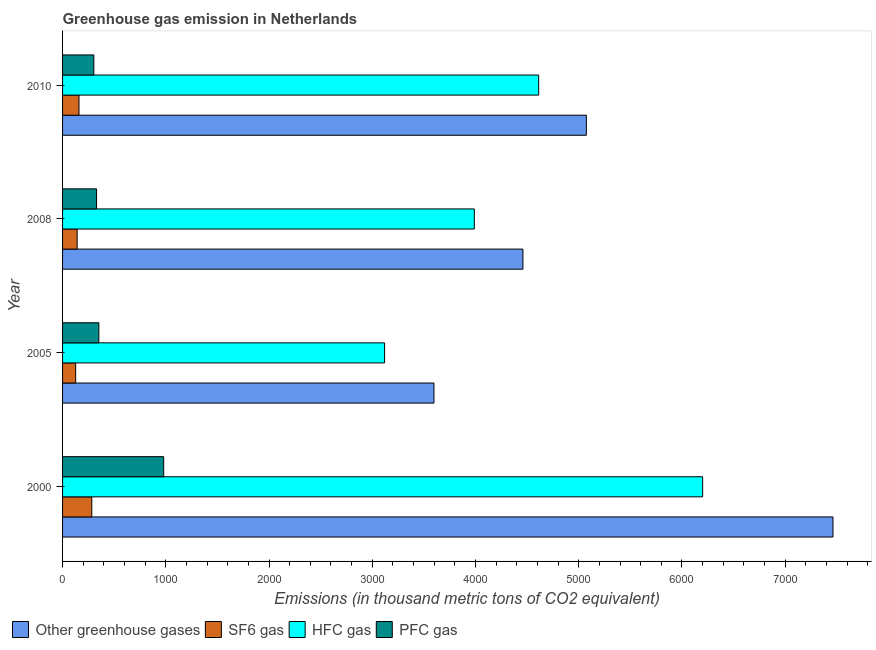How many different coloured bars are there?
Give a very brief answer. 4. Are the number of bars per tick equal to the number of legend labels?
Your answer should be very brief. Yes. How many bars are there on the 4th tick from the top?
Provide a succinct answer. 4. How many bars are there on the 3rd tick from the bottom?
Your answer should be very brief. 4. What is the label of the 1st group of bars from the top?
Give a very brief answer. 2010. What is the emission of greenhouse gases in 2008?
Keep it short and to the point. 4459.4. Across all years, what is the maximum emission of sf6 gas?
Provide a short and direct response. 283. Across all years, what is the minimum emission of pfc gas?
Ensure brevity in your answer.  303. In which year was the emission of hfc gas maximum?
Offer a very short reply. 2000. In which year was the emission of pfc gas minimum?
Keep it short and to the point. 2010. What is the total emission of hfc gas in the graph?
Provide a short and direct response. 1.79e+04. What is the difference between the emission of hfc gas in 2000 and that in 2005?
Offer a very short reply. 3080.9. What is the difference between the emission of hfc gas in 2010 and the emission of sf6 gas in 2008?
Offer a very short reply. 4470.6. What is the average emission of hfc gas per year?
Ensure brevity in your answer.  4480.18. In the year 2000, what is the difference between the emission of sf6 gas and emission of greenhouse gases?
Ensure brevity in your answer.  -7179.9. In how many years, is the emission of sf6 gas greater than 1000 thousand metric tons?
Keep it short and to the point. 0. What is the ratio of the emission of greenhouse gases in 2008 to that in 2010?
Ensure brevity in your answer.  0.88. Is the emission of pfc gas in 2005 less than that in 2008?
Ensure brevity in your answer.  No. What is the difference between the highest and the second highest emission of greenhouse gases?
Offer a very short reply. 2388.9. What is the difference between the highest and the lowest emission of sf6 gas?
Keep it short and to the point. 156.1. What does the 1st bar from the top in 2010 represents?
Offer a very short reply. PFC gas. What does the 4th bar from the bottom in 2010 represents?
Your answer should be very brief. PFC gas. Is it the case that in every year, the sum of the emission of greenhouse gases and emission of sf6 gas is greater than the emission of hfc gas?
Offer a terse response. Yes. How many bars are there?
Offer a terse response. 16. Are all the bars in the graph horizontal?
Provide a short and direct response. Yes. What is the difference between two consecutive major ticks on the X-axis?
Offer a very short reply. 1000. Are the values on the major ticks of X-axis written in scientific E-notation?
Your answer should be compact. No. Does the graph contain grids?
Offer a terse response. No. Where does the legend appear in the graph?
Give a very brief answer. Bottom left. What is the title of the graph?
Make the answer very short. Greenhouse gas emission in Netherlands. Does "Plant species" appear as one of the legend labels in the graph?
Keep it short and to the point. No. What is the label or title of the X-axis?
Offer a very short reply. Emissions (in thousand metric tons of CO2 equivalent). What is the Emissions (in thousand metric tons of CO2 equivalent) of Other greenhouse gases in 2000?
Give a very brief answer. 7462.9. What is the Emissions (in thousand metric tons of CO2 equivalent) of SF6 gas in 2000?
Provide a succinct answer. 283. What is the Emissions (in thousand metric tons of CO2 equivalent) of HFC gas in 2000?
Offer a very short reply. 6200.4. What is the Emissions (in thousand metric tons of CO2 equivalent) in PFC gas in 2000?
Offer a very short reply. 979.5. What is the Emissions (in thousand metric tons of CO2 equivalent) in Other greenhouse gases in 2005?
Keep it short and to the point. 3597.8. What is the Emissions (in thousand metric tons of CO2 equivalent) in SF6 gas in 2005?
Your response must be concise. 126.9. What is the Emissions (in thousand metric tons of CO2 equivalent) in HFC gas in 2005?
Your answer should be compact. 3119.5. What is the Emissions (in thousand metric tons of CO2 equivalent) in PFC gas in 2005?
Make the answer very short. 351.4. What is the Emissions (in thousand metric tons of CO2 equivalent) in Other greenhouse gases in 2008?
Provide a succinct answer. 4459.4. What is the Emissions (in thousand metric tons of CO2 equivalent) of SF6 gas in 2008?
Ensure brevity in your answer.  141.4. What is the Emissions (in thousand metric tons of CO2 equivalent) of HFC gas in 2008?
Offer a very short reply. 3988.8. What is the Emissions (in thousand metric tons of CO2 equivalent) in PFC gas in 2008?
Provide a short and direct response. 329.2. What is the Emissions (in thousand metric tons of CO2 equivalent) in Other greenhouse gases in 2010?
Your response must be concise. 5074. What is the Emissions (in thousand metric tons of CO2 equivalent) in SF6 gas in 2010?
Your response must be concise. 159. What is the Emissions (in thousand metric tons of CO2 equivalent) of HFC gas in 2010?
Provide a succinct answer. 4612. What is the Emissions (in thousand metric tons of CO2 equivalent) of PFC gas in 2010?
Offer a very short reply. 303. Across all years, what is the maximum Emissions (in thousand metric tons of CO2 equivalent) in Other greenhouse gases?
Provide a succinct answer. 7462.9. Across all years, what is the maximum Emissions (in thousand metric tons of CO2 equivalent) in SF6 gas?
Keep it short and to the point. 283. Across all years, what is the maximum Emissions (in thousand metric tons of CO2 equivalent) in HFC gas?
Provide a short and direct response. 6200.4. Across all years, what is the maximum Emissions (in thousand metric tons of CO2 equivalent) of PFC gas?
Provide a succinct answer. 979.5. Across all years, what is the minimum Emissions (in thousand metric tons of CO2 equivalent) of Other greenhouse gases?
Your answer should be compact. 3597.8. Across all years, what is the minimum Emissions (in thousand metric tons of CO2 equivalent) of SF6 gas?
Make the answer very short. 126.9. Across all years, what is the minimum Emissions (in thousand metric tons of CO2 equivalent) of HFC gas?
Make the answer very short. 3119.5. Across all years, what is the minimum Emissions (in thousand metric tons of CO2 equivalent) in PFC gas?
Offer a terse response. 303. What is the total Emissions (in thousand metric tons of CO2 equivalent) of Other greenhouse gases in the graph?
Make the answer very short. 2.06e+04. What is the total Emissions (in thousand metric tons of CO2 equivalent) in SF6 gas in the graph?
Make the answer very short. 710.3. What is the total Emissions (in thousand metric tons of CO2 equivalent) in HFC gas in the graph?
Give a very brief answer. 1.79e+04. What is the total Emissions (in thousand metric tons of CO2 equivalent) of PFC gas in the graph?
Provide a succinct answer. 1963.1. What is the difference between the Emissions (in thousand metric tons of CO2 equivalent) of Other greenhouse gases in 2000 and that in 2005?
Offer a terse response. 3865.1. What is the difference between the Emissions (in thousand metric tons of CO2 equivalent) of SF6 gas in 2000 and that in 2005?
Ensure brevity in your answer.  156.1. What is the difference between the Emissions (in thousand metric tons of CO2 equivalent) of HFC gas in 2000 and that in 2005?
Your answer should be very brief. 3080.9. What is the difference between the Emissions (in thousand metric tons of CO2 equivalent) of PFC gas in 2000 and that in 2005?
Your answer should be very brief. 628.1. What is the difference between the Emissions (in thousand metric tons of CO2 equivalent) in Other greenhouse gases in 2000 and that in 2008?
Provide a short and direct response. 3003.5. What is the difference between the Emissions (in thousand metric tons of CO2 equivalent) in SF6 gas in 2000 and that in 2008?
Make the answer very short. 141.6. What is the difference between the Emissions (in thousand metric tons of CO2 equivalent) of HFC gas in 2000 and that in 2008?
Keep it short and to the point. 2211.6. What is the difference between the Emissions (in thousand metric tons of CO2 equivalent) of PFC gas in 2000 and that in 2008?
Give a very brief answer. 650.3. What is the difference between the Emissions (in thousand metric tons of CO2 equivalent) in Other greenhouse gases in 2000 and that in 2010?
Make the answer very short. 2388.9. What is the difference between the Emissions (in thousand metric tons of CO2 equivalent) of SF6 gas in 2000 and that in 2010?
Provide a succinct answer. 124. What is the difference between the Emissions (in thousand metric tons of CO2 equivalent) in HFC gas in 2000 and that in 2010?
Offer a terse response. 1588.4. What is the difference between the Emissions (in thousand metric tons of CO2 equivalent) in PFC gas in 2000 and that in 2010?
Keep it short and to the point. 676.5. What is the difference between the Emissions (in thousand metric tons of CO2 equivalent) of Other greenhouse gases in 2005 and that in 2008?
Give a very brief answer. -861.6. What is the difference between the Emissions (in thousand metric tons of CO2 equivalent) of HFC gas in 2005 and that in 2008?
Ensure brevity in your answer.  -869.3. What is the difference between the Emissions (in thousand metric tons of CO2 equivalent) of Other greenhouse gases in 2005 and that in 2010?
Your answer should be very brief. -1476.2. What is the difference between the Emissions (in thousand metric tons of CO2 equivalent) of SF6 gas in 2005 and that in 2010?
Your response must be concise. -32.1. What is the difference between the Emissions (in thousand metric tons of CO2 equivalent) in HFC gas in 2005 and that in 2010?
Your answer should be compact. -1492.5. What is the difference between the Emissions (in thousand metric tons of CO2 equivalent) of PFC gas in 2005 and that in 2010?
Your answer should be compact. 48.4. What is the difference between the Emissions (in thousand metric tons of CO2 equivalent) of Other greenhouse gases in 2008 and that in 2010?
Provide a short and direct response. -614.6. What is the difference between the Emissions (in thousand metric tons of CO2 equivalent) of SF6 gas in 2008 and that in 2010?
Offer a very short reply. -17.6. What is the difference between the Emissions (in thousand metric tons of CO2 equivalent) of HFC gas in 2008 and that in 2010?
Keep it short and to the point. -623.2. What is the difference between the Emissions (in thousand metric tons of CO2 equivalent) in PFC gas in 2008 and that in 2010?
Make the answer very short. 26.2. What is the difference between the Emissions (in thousand metric tons of CO2 equivalent) in Other greenhouse gases in 2000 and the Emissions (in thousand metric tons of CO2 equivalent) in SF6 gas in 2005?
Your answer should be very brief. 7336. What is the difference between the Emissions (in thousand metric tons of CO2 equivalent) in Other greenhouse gases in 2000 and the Emissions (in thousand metric tons of CO2 equivalent) in HFC gas in 2005?
Give a very brief answer. 4343.4. What is the difference between the Emissions (in thousand metric tons of CO2 equivalent) of Other greenhouse gases in 2000 and the Emissions (in thousand metric tons of CO2 equivalent) of PFC gas in 2005?
Make the answer very short. 7111.5. What is the difference between the Emissions (in thousand metric tons of CO2 equivalent) in SF6 gas in 2000 and the Emissions (in thousand metric tons of CO2 equivalent) in HFC gas in 2005?
Provide a short and direct response. -2836.5. What is the difference between the Emissions (in thousand metric tons of CO2 equivalent) in SF6 gas in 2000 and the Emissions (in thousand metric tons of CO2 equivalent) in PFC gas in 2005?
Provide a short and direct response. -68.4. What is the difference between the Emissions (in thousand metric tons of CO2 equivalent) of HFC gas in 2000 and the Emissions (in thousand metric tons of CO2 equivalent) of PFC gas in 2005?
Your response must be concise. 5849. What is the difference between the Emissions (in thousand metric tons of CO2 equivalent) of Other greenhouse gases in 2000 and the Emissions (in thousand metric tons of CO2 equivalent) of SF6 gas in 2008?
Make the answer very short. 7321.5. What is the difference between the Emissions (in thousand metric tons of CO2 equivalent) of Other greenhouse gases in 2000 and the Emissions (in thousand metric tons of CO2 equivalent) of HFC gas in 2008?
Your answer should be compact. 3474.1. What is the difference between the Emissions (in thousand metric tons of CO2 equivalent) in Other greenhouse gases in 2000 and the Emissions (in thousand metric tons of CO2 equivalent) in PFC gas in 2008?
Provide a short and direct response. 7133.7. What is the difference between the Emissions (in thousand metric tons of CO2 equivalent) of SF6 gas in 2000 and the Emissions (in thousand metric tons of CO2 equivalent) of HFC gas in 2008?
Your answer should be very brief. -3705.8. What is the difference between the Emissions (in thousand metric tons of CO2 equivalent) of SF6 gas in 2000 and the Emissions (in thousand metric tons of CO2 equivalent) of PFC gas in 2008?
Keep it short and to the point. -46.2. What is the difference between the Emissions (in thousand metric tons of CO2 equivalent) of HFC gas in 2000 and the Emissions (in thousand metric tons of CO2 equivalent) of PFC gas in 2008?
Your response must be concise. 5871.2. What is the difference between the Emissions (in thousand metric tons of CO2 equivalent) of Other greenhouse gases in 2000 and the Emissions (in thousand metric tons of CO2 equivalent) of SF6 gas in 2010?
Provide a short and direct response. 7303.9. What is the difference between the Emissions (in thousand metric tons of CO2 equivalent) in Other greenhouse gases in 2000 and the Emissions (in thousand metric tons of CO2 equivalent) in HFC gas in 2010?
Provide a short and direct response. 2850.9. What is the difference between the Emissions (in thousand metric tons of CO2 equivalent) in Other greenhouse gases in 2000 and the Emissions (in thousand metric tons of CO2 equivalent) in PFC gas in 2010?
Provide a short and direct response. 7159.9. What is the difference between the Emissions (in thousand metric tons of CO2 equivalent) of SF6 gas in 2000 and the Emissions (in thousand metric tons of CO2 equivalent) of HFC gas in 2010?
Provide a short and direct response. -4329. What is the difference between the Emissions (in thousand metric tons of CO2 equivalent) in HFC gas in 2000 and the Emissions (in thousand metric tons of CO2 equivalent) in PFC gas in 2010?
Your response must be concise. 5897.4. What is the difference between the Emissions (in thousand metric tons of CO2 equivalent) of Other greenhouse gases in 2005 and the Emissions (in thousand metric tons of CO2 equivalent) of SF6 gas in 2008?
Offer a terse response. 3456.4. What is the difference between the Emissions (in thousand metric tons of CO2 equivalent) of Other greenhouse gases in 2005 and the Emissions (in thousand metric tons of CO2 equivalent) of HFC gas in 2008?
Offer a very short reply. -391. What is the difference between the Emissions (in thousand metric tons of CO2 equivalent) in Other greenhouse gases in 2005 and the Emissions (in thousand metric tons of CO2 equivalent) in PFC gas in 2008?
Your response must be concise. 3268.6. What is the difference between the Emissions (in thousand metric tons of CO2 equivalent) in SF6 gas in 2005 and the Emissions (in thousand metric tons of CO2 equivalent) in HFC gas in 2008?
Your answer should be compact. -3861.9. What is the difference between the Emissions (in thousand metric tons of CO2 equivalent) of SF6 gas in 2005 and the Emissions (in thousand metric tons of CO2 equivalent) of PFC gas in 2008?
Provide a short and direct response. -202.3. What is the difference between the Emissions (in thousand metric tons of CO2 equivalent) in HFC gas in 2005 and the Emissions (in thousand metric tons of CO2 equivalent) in PFC gas in 2008?
Ensure brevity in your answer.  2790.3. What is the difference between the Emissions (in thousand metric tons of CO2 equivalent) in Other greenhouse gases in 2005 and the Emissions (in thousand metric tons of CO2 equivalent) in SF6 gas in 2010?
Make the answer very short. 3438.8. What is the difference between the Emissions (in thousand metric tons of CO2 equivalent) in Other greenhouse gases in 2005 and the Emissions (in thousand metric tons of CO2 equivalent) in HFC gas in 2010?
Give a very brief answer. -1014.2. What is the difference between the Emissions (in thousand metric tons of CO2 equivalent) of Other greenhouse gases in 2005 and the Emissions (in thousand metric tons of CO2 equivalent) of PFC gas in 2010?
Provide a short and direct response. 3294.8. What is the difference between the Emissions (in thousand metric tons of CO2 equivalent) of SF6 gas in 2005 and the Emissions (in thousand metric tons of CO2 equivalent) of HFC gas in 2010?
Ensure brevity in your answer.  -4485.1. What is the difference between the Emissions (in thousand metric tons of CO2 equivalent) in SF6 gas in 2005 and the Emissions (in thousand metric tons of CO2 equivalent) in PFC gas in 2010?
Offer a very short reply. -176.1. What is the difference between the Emissions (in thousand metric tons of CO2 equivalent) in HFC gas in 2005 and the Emissions (in thousand metric tons of CO2 equivalent) in PFC gas in 2010?
Give a very brief answer. 2816.5. What is the difference between the Emissions (in thousand metric tons of CO2 equivalent) in Other greenhouse gases in 2008 and the Emissions (in thousand metric tons of CO2 equivalent) in SF6 gas in 2010?
Offer a very short reply. 4300.4. What is the difference between the Emissions (in thousand metric tons of CO2 equivalent) in Other greenhouse gases in 2008 and the Emissions (in thousand metric tons of CO2 equivalent) in HFC gas in 2010?
Keep it short and to the point. -152.6. What is the difference between the Emissions (in thousand metric tons of CO2 equivalent) in Other greenhouse gases in 2008 and the Emissions (in thousand metric tons of CO2 equivalent) in PFC gas in 2010?
Your response must be concise. 4156.4. What is the difference between the Emissions (in thousand metric tons of CO2 equivalent) in SF6 gas in 2008 and the Emissions (in thousand metric tons of CO2 equivalent) in HFC gas in 2010?
Provide a succinct answer. -4470.6. What is the difference between the Emissions (in thousand metric tons of CO2 equivalent) in SF6 gas in 2008 and the Emissions (in thousand metric tons of CO2 equivalent) in PFC gas in 2010?
Your response must be concise. -161.6. What is the difference between the Emissions (in thousand metric tons of CO2 equivalent) in HFC gas in 2008 and the Emissions (in thousand metric tons of CO2 equivalent) in PFC gas in 2010?
Make the answer very short. 3685.8. What is the average Emissions (in thousand metric tons of CO2 equivalent) of Other greenhouse gases per year?
Keep it short and to the point. 5148.52. What is the average Emissions (in thousand metric tons of CO2 equivalent) in SF6 gas per year?
Ensure brevity in your answer.  177.57. What is the average Emissions (in thousand metric tons of CO2 equivalent) in HFC gas per year?
Give a very brief answer. 4480.18. What is the average Emissions (in thousand metric tons of CO2 equivalent) of PFC gas per year?
Your response must be concise. 490.77. In the year 2000, what is the difference between the Emissions (in thousand metric tons of CO2 equivalent) in Other greenhouse gases and Emissions (in thousand metric tons of CO2 equivalent) in SF6 gas?
Provide a short and direct response. 7179.9. In the year 2000, what is the difference between the Emissions (in thousand metric tons of CO2 equivalent) in Other greenhouse gases and Emissions (in thousand metric tons of CO2 equivalent) in HFC gas?
Provide a succinct answer. 1262.5. In the year 2000, what is the difference between the Emissions (in thousand metric tons of CO2 equivalent) in Other greenhouse gases and Emissions (in thousand metric tons of CO2 equivalent) in PFC gas?
Your response must be concise. 6483.4. In the year 2000, what is the difference between the Emissions (in thousand metric tons of CO2 equivalent) of SF6 gas and Emissions (in thousand metric tons of CO2 equivalent) of HFC gas?
Keep it short and to the point. -5917.4. In the year 2000, what is the difference between the Emissions (in thousand metric tons of CO2 equivalent) of SF6 gas and Emissions (in thousand metric tons of CO2 equivalent) of PFC gas?
Give a very brief answer. -696.5. In the year 2000, what is the difference between the Emissions (in thousand metric tons of CO2 equivalent) of HFC gas and Emissions (in thousand metric tons of CO2 equivalent) of PFC gas?
Your answer should be very brief. 5220.9. In the year 2005, what is the difference between the Emissions (in thousand metric tons of CO2 equivalent) of Other greenhouse gases and Emissions (in thousand metric tons of CO2 equivalent) of SF6 gas?
Keep it short and to the point. 3470.9. In the year 2005, what is the difference between the Emissions (in thousand metric tons of CO2 equivalent) in Other greenhouse gases and Emissions (in thousand metric tons of CO2 equivalent) in HFC gas?
Keep it short and to the point. 478.3. In the year 2005, what is the difference between the Emissions (in thousand metric tons of CO2 equivalent) in Other greenhouse gases and Emissions (in thousand metric tons of CO2 equivalent) in PFC gas?
Offer a terse response. 3246.4. In the year 2005, what is the difference between the Emissions (in thousand metric tons of CO2 equivalent) of SF6 gas and Emissions (in thousand metric tons of CO2 equivalent) of HFC gas?
Your answer should be compact. -2992.6. In the year 2005, what is the difference between the Emissions (in thousand metric tons of CO2 equivalent) of SF6 gas and Emissions (in thousand metric tons of CO2 equivalent) of PFC gas?
Make the answer very short. -224.5. In the year 2005, what is the difference between the Emissions (in thousand metric tons of CO2 equivalent) in HFC gas and Emissions (in thousand metric tons of CO2 equivalent) in PFC gas?
Offer a terse response. 2768.1. In the year 2008, what is the difference between the Emissions (in thousand metric tons of CO2 equivalent) in Other greenhouse gases and Emissions (in thousand metric tons of CO2 equivalent) in SF6 gas?
Offer a terse response. 4318. In the year 2008, what is the difference between the Emissions (in thousand metric tons of CO2 equivalent) of Other greenhouse gases and Emissions (in thousand metric tons of CO2 equivalent) of HFC gas?
Ensure brevity in your answer.  470.6. In the year 2008, what is the difference between the Emissions (in thousand metric tons of CO2 equivalent) in Other greenhouse gases and Emissions (in thousand metric tons of CO2 equivalent) in PFC gas?
Your answer should be compact. 4130.2. In the year 2008, what is the difference between the Emissions (in thousand metric tons of CO2 equivalent) in SF6 gas and Emissions (in thousand metric tons of CO2 equivalent) in HFC gas?
Your answer should be compact. -3847.4. In the year 2008, what is the difference between the Emissions (in thousand metric tons of CO2 equivalent) of SF6 gas and Emissions (in thousand metric tons of CO2 equivalent) of PFC gas?
Provide a short and direct response. -187.8. In the year 2008, what is the difference between the Emissions (in thousand metric tons of CO2 equivalent) of HFC gas and Emissions (in thousand metric tons of CO2 equivalent) of PFC gas?
Keep it short and to the point. 3659.6. In the year 2010, what is the difference between the Emissions (in thousand metric tons of CO2 equivalent) in Other greenhouse gases and Emissions (in thousand metric tons of CO2 equivalent) in SF6 gas?
Provide a short and direct response. 4915. In the year 2010, what is the difference between the Emissions (in thousand metric tons of CO2 equivalent) in Other greenhouse gases and Emissions (in thousand metric tons of CO2 equivalent) in HFC gas?
Your answer should be very brief. 462. In the year 2010, what is the difference between the Emissions (in thousand metric tons of CO2 equivalent) in Other greenhouse gases and Emissions (in thousand metric tons of CO2 equivalent) in PFC gas?
Give a very brief answer. 4771. In the year 2010, what is the difference between the Emissions (in thousand metric tons of CO2 equivalent) of SF6 gas and Emissions (in thousand metric tons of CO2 equivalent) of HFC gas?
Make the answer very short. -4453. In the year 2010, what is the difference between the Emissions (in thousand metric tons of CO2 equivalent) in SF6 gas and Emissions (in thousand metric tons of CO2 equivalent) in PFC gas?
Provide a short and direct response. -144. In the year 2010, what is the difference between the Emissions (in thousand metric tons of CO2 equivalent) of HFC gas and Emissions (in thousand metric tons of CO2 equivalent) of PFC gas?
Keep it short and to the point. 4309. What is the ratio of the Emissions (in thousand metric tons of CO2 equivalent) of Other greenhouse gases in 2000 to that in 2005?
Offer a terse response. 2.07. What is the ratio of the Emissions (in thousand metric tons of CO2 equivalent) of SF6 gas in 2000 to that in 2005?
Provide a succinct answer. 2.23. What is the ratio of the Emissions (in thousand metric tons of CO2 equivalent) in HFC gas in 2000 to that in 2005?
Your response must be concise. 1.99. What is the ratio of the Emissions (in thousand metric tons of CO2 equivalent) of PFC gas in 2000 to that in 2005?
Ensure brevity in your answer.  2.79. What is the ratio of the Emissions (in thousand metric tons of CO2 equivalent) of Other greenhouse gases in 2000 to that in 2008?
Give a very brief answer. 1.67. What is the ratio of the Emissions (in thousand metric tons of CO2 equivalent) in SF6 gas in 2000 to that in 2008?
Keep it short and to the point. 2. What is the ratio of the Emissions (in thousand metric tons of CO2 equivalent) in HFC gas in 2000 to that in 2008?
Provide a short and direct response. 1.55. What is the ratio of the Emissions (in thousand metric tons of CO2 equivalent) in PFC gas in 2000 to that in 2008?
Make the answer very short. 2.98. What is the ratio of the Emissions (in thousand metric tons of CO2 equivalent) in Other greenhouse gases in 2000 to that in 2010?
Your answer should be very brief. 1.47. What is the ratio of the Emissions (in thousand metric tons of CO2 equivalent) of SF6 gas in 2000 to that in 2010?
Give a very brief answer. 1.78. What is the ratio of the Emissions (in thousand metric tons of CO2 equivalent) in HFC gas in 2000 to that in 2010?
Keep it short and to the point. 1.34. What is the ratio of the Emissions (in thousand metric tons of CO2 equivalent) of PFC gas in 2000 to that in 2010?
Your answer should be very brief. 3.23. What is the ratio of the Emissions (in thousand metric tons of CO2 equivalent) of Other greenhouse gases in 2005 to that in 2008?
Your answer should be compact. 0.81. What is the ratio of the Emissions (in thousand metric tons of CO2 equivalent) in SF6 gas in 2005 to that in 2008?
Ensure brevity in your answer.  0.9. What is the ratio of the Emissions (in thousand metric tons of CO2 equivalent) of HFC gas in 2005 to that in 2008?
Make the answer very short. 0.78. What is the ratio of the Emissions (in thousand metric tons of CO2 equivalent) in PFC gas in 2005 to that in 2008?
Ensure brevity in your answer.  1.07. What is the ratio of the Emissions (in thousand metric tons of CO2 equivalent) in Other greenhouse gases in 2005 to that in 2010?
Keep it short and to the point. 0.71. What is the ratio of the Emissions (in thousand metric tons of CO2 equivalent) of SF6 gas in 2005 to that in 2010?
Make the answer very short. 0.8. What is the ratio of the Emissions (in thousand metric tons of CO2 equivalent) in HFC gas in 2005 to that in 2010?
Provide a succinct answer. 0.68. What is the ratio of the Emissions (in thousand metric tons of CO2 equivalent) of PFC gas in 2005 to that in 2010?
Make the answer very short. 1.16. What is the ratio of the Emissions (in thousand metric tons of CO2 equivalent) in Other greenhouse gases in 2008 to that in 2010?
Ensure brevity in your answer.  0.88. What is the ratio of the Emissions (in thousand metric tons of CO2 equivalent) of SF6 gas in 2008 to that in 2010?
Make the answer very short. 0.89. What is the ratio of the Emissions (in thousand metric tons of CO2 equivalent) in HFC gas in 2008 to that in 2010?
Make the answer very short. 0.86. What is the ratio of the Emissions (in thousand metric tons of CO2 equivalent) in PFC gas in 2008 to that in 2010?
Give a very brief answer. 1.09. What is the difference between the highest and the second highest Emissions (in thousand metric tons of CO2 equivalent) in Other greenhouse gases?
Your answer should be compact. 2388.9. What is the difference between the highest and the second highest Emissions (in thousand metric tons of CO2 equivalent) of SF6 gas?
Ensure brevity in your answer.  124. What is the difference between the highest and the second highest Emissions (in thousand metric tons of CO2 equivalent) in HFC gas?
Provide a short and direct response. 1588.4. What is the difference between the highest and the second highest Emissions (in thousand metric tons of CO2 equivalent) of PFC gas?
Provide a short and direct response. 628.1. What is the difference between the highest and the lowest Emissions (in thousand metric tons of CO2 equivalent) of Other greenhouse gases?
Your answer should be compact. 3865.1. What is the difference between the highest and the lowest Emissions (in thousand metric tons of CO2 equivalent) in SF6 gas?
Offer a terse response. 156.1. What is the difference between the highest and the lowest Emissions (in thousand metric tons of CO2 equivalent) in HFC gas?
Keep it short and to the point. 3080.9. What is the difference between the highest and the lowest Emissions (in thousand metric tons of CO2 equivalent) of PFC gas?
Your response must be concise. 676.5. 